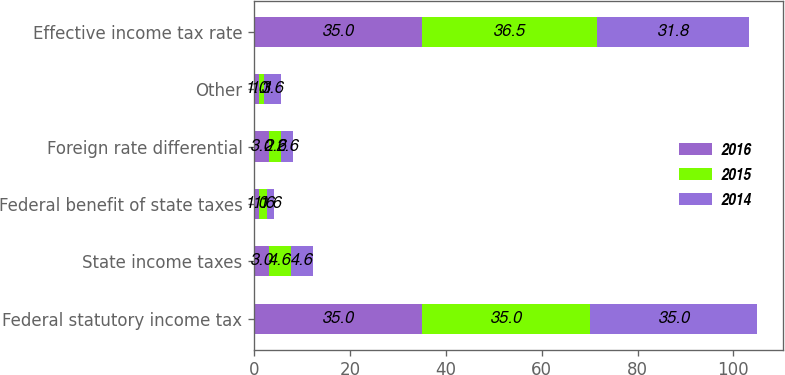<chart> <loc_0><loc_0><loc_500><loc_500><stacked_bar_chart><ecel><fcel>Federal statutory income tax<fcel>State income taxes<fcel>Federal benefit of state taxes<fcel>Foreign rate differential<fcel>Other<fcel>Effective income tax rate<nl><fcel>2016<fcel>35<fcel>3<fcel>1<fcel>3<fcel>1<fcel>35<nl><fcel>2015<fcel>35<fcel>4.6<fcel>1.6<fcel>2.6<fcel>1.1<fcel>36.5<nl><fcel>2014<fcel>35<fcel>4.6<fcel>1.6<fcel>2.6<fcel>3.6<fcel>31.8<nl></chart> 